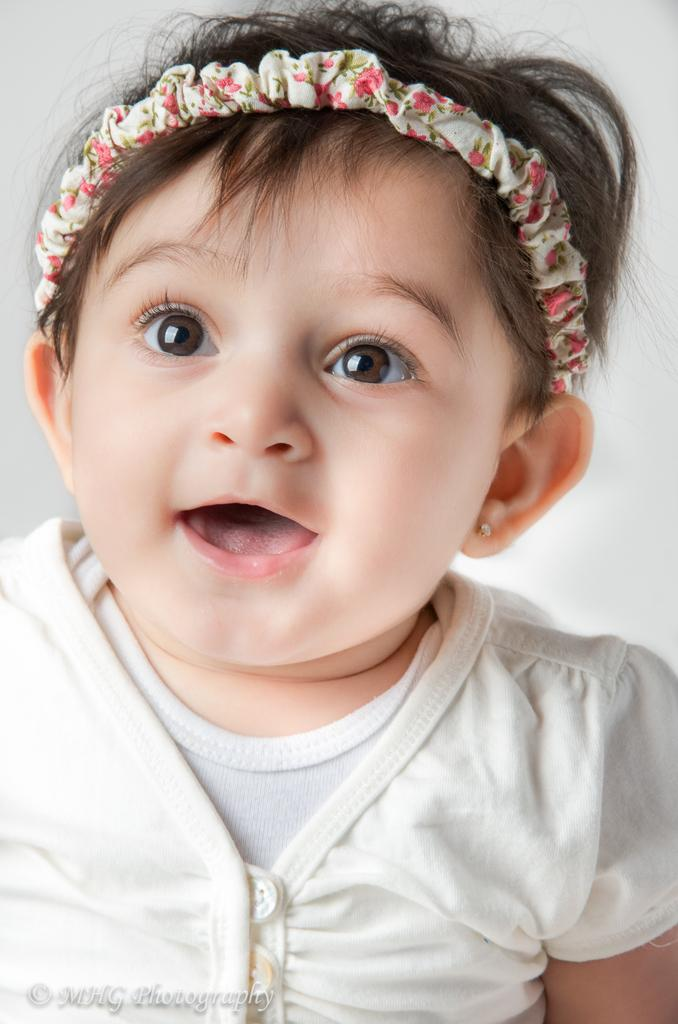Who is the main subject in the image? There is a girl in the image. What accessory is the girl wearing? The girl is wearing a hairband. Where can we find text in the image? There is text in the left bottom corner of the image. What color is the background of the image? The background of the image is white. What is the girl's reaction to the oranges in the image? There are no oranges present in the image, so it is not possible to determine the girl's reaction to them. 